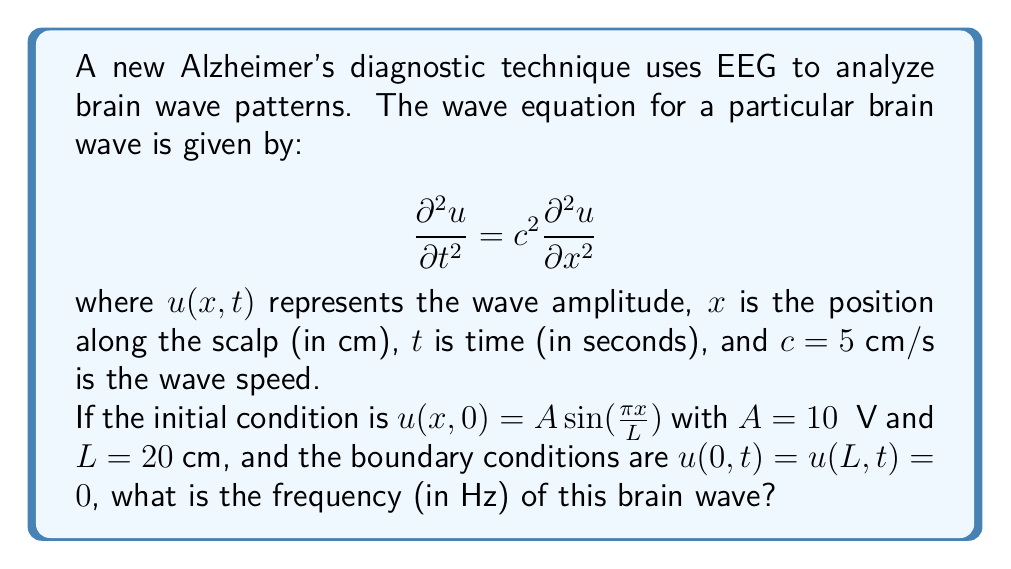Give your solution to this math problem. To solve this problem, we'll follow these steps:

1) The general solution for the wave equation with the given boundary conditions is:

   $$u(x,t) = \sum_{n=1}^{\infty} A_n \sin(\frac{n\pi x}{L}) \cos(\frac{n\pi c t}{L})$$

2) Comparing this with our initial condition, we see that only the first term ($n=1$) is present:

   $$u(x,0) = A \sin(\frac{\pi x}{L})$$

3) The frequency $f$ is related to the angular frequency $\omega$ by $f = \frac{\omega}{2\pi}$. In our solution, $\omega = \frac{\pi c}{L}$.

4) Therefore, the frequency is:

   $$f = \frac{\omega}{2\pi} = \frac{1}{2L} \cdot c$$

5) Substituting the given values:

   $$f = \frac{1}{2 \cdot 20 \text{ cm}} \cdot 5 \text{ cm/s} = \frac{5}{40} \text{ Hz} = 0.125 \text{ Hz}$$

Thus, the frequency of this brain wave is 0.125 Hz.
Answer: 0.125 Hz 